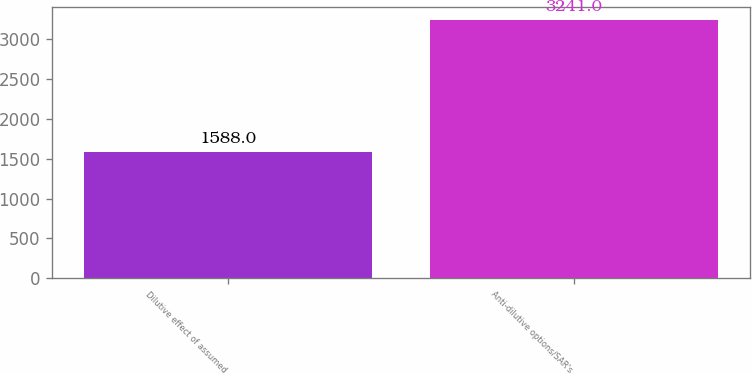<chart> <loc_0><loc_0><loc_500><loc_500><bar_chart><fcel>Dilutive effect of assumed<fcel>Anti-dilutive options/SAR's<nl><fcel>1588<fcel>3241<nl></chart> 